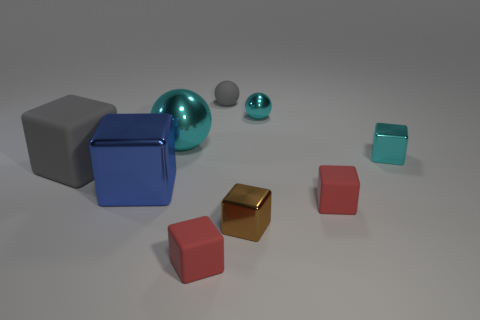How would you describe the composition of this image? The composition of this image is both simple and balanced, with objects placed in a way that draws the eye across the space. The arrangement of the objects with differing sizes and colors creates visual interest, while allowing each object to stand out on its own. The use of negative space around the objects adds to the harmony of the composition, providing a minimalist aesthetic. 